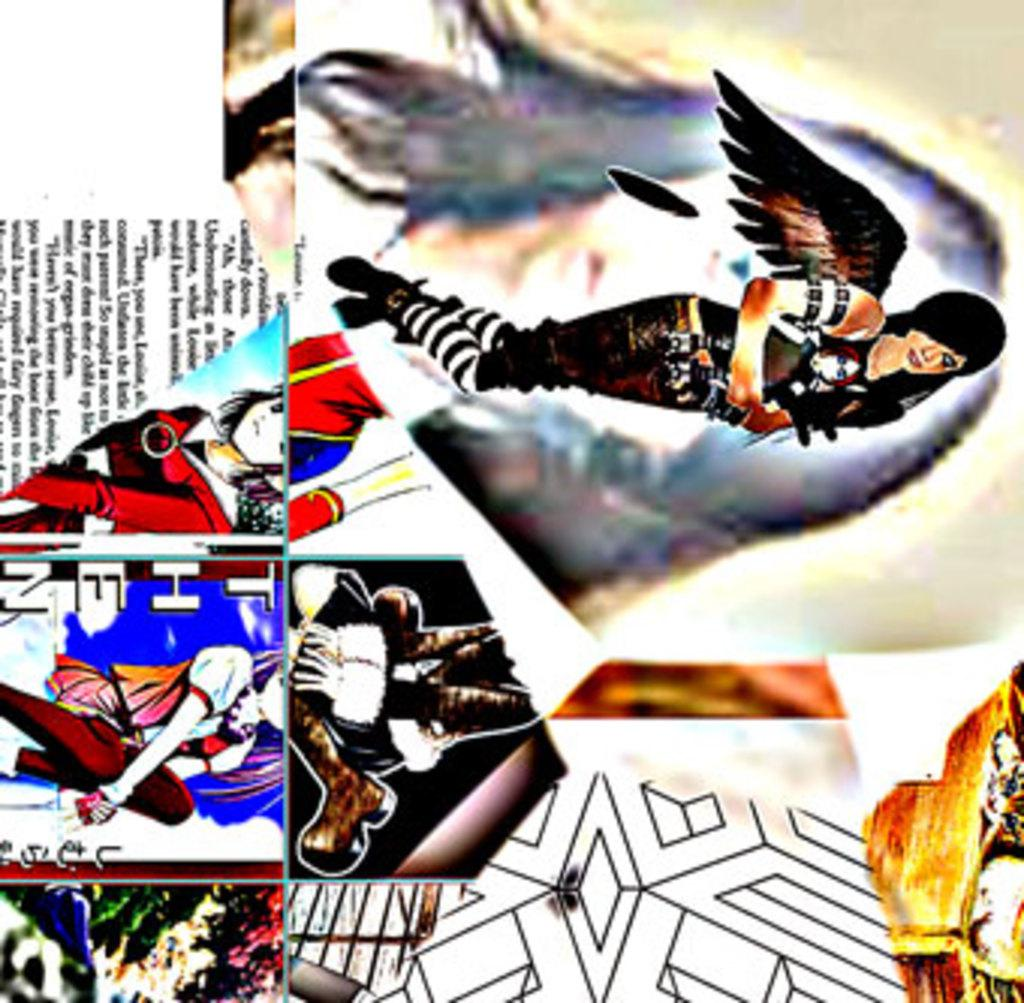What type of artwork is shown in the image? The image is a collage containing multiple pictures. What subjects are featured in the pictures? The pictures depict persons. Are there any visual elements besides the pictures in the collage? Yes, the pictures contain designs. Is there any written content in the collage? There is text present in the collage. Where is the lunchroom located in the image? There is no lunchroom present in the image; it is a collage of pictures featuring persons. What type of addition is being made to the growth in the image? There is no growth or addition present in the image; it is a collage of pictures featuring persons. 